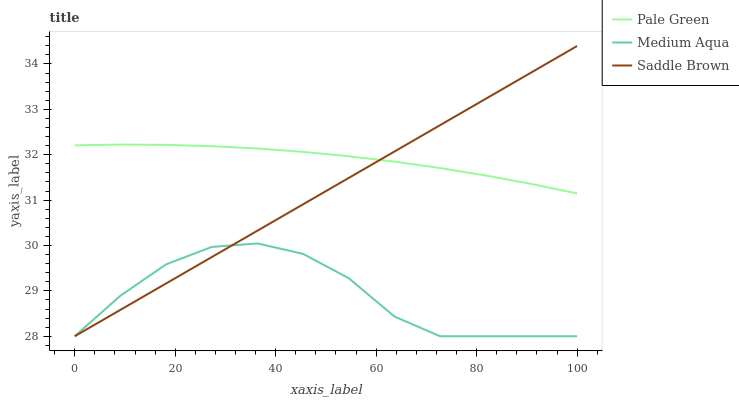Does Saddle Brown have the minimum area under the curve?
Answer yes or no. No. Does Saddle Brown have the maximum area under the curve?
Answer yes or no. No. Is Medium Aqua the smoothest?
Answer yes or no. No. Is Saddle Brown the roughest?
Answer yes or no. No. Does Medium Aqua have the highest value?
Answer yes or no. No. Is Medium Aqua less than Pale Green?
Answer yes or no. Yes. Is Pale Green greater than Medium Aqua?
Answer yes or no. Yes. Does Medium Aqua intersect Pale Green?
Answer yes or no. No. 